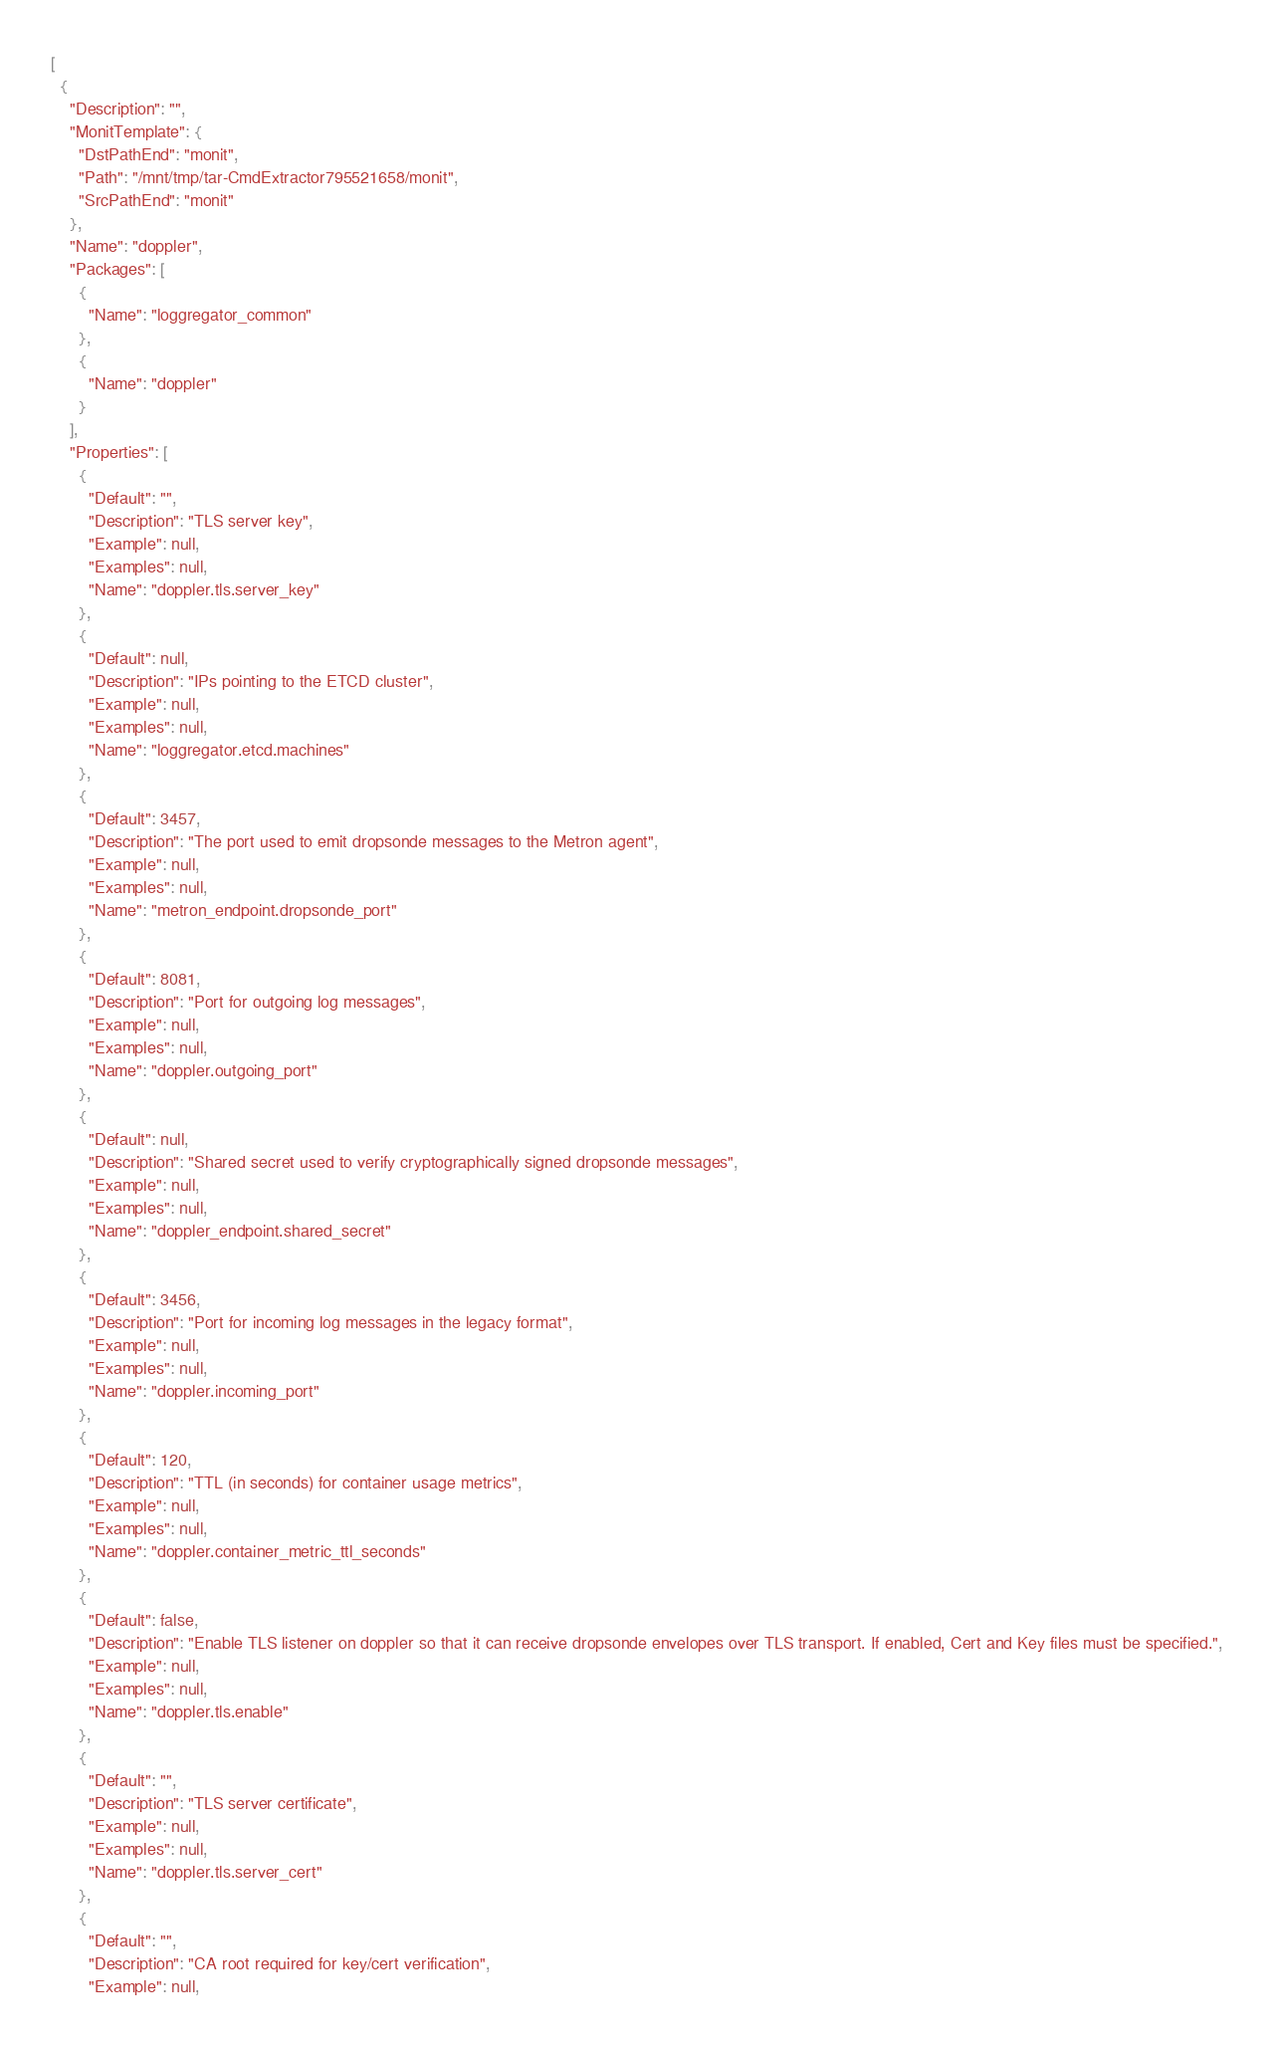Convert code to text. <code><loc_0><loc_0><loc_500><loc_500><_YAML_>[
  {
    "Description": "",
    "MonitTemplate": {
      "DstPathEnd": "monit",
      "Path": "/mnt/tmp/tar-CmdExtractor795521658/monit",
      "SrcPathEnd": "monit"
    },
    "Name": "doppler",
    "Packages": [
      {
        "Name": "loggregator_common"
      },
      {
        "Name": "doppler"
      }
    ],
    "Properties": [
      {
        "Default": "",
        "Description": "TLS server key",
        "Example": null,
        "Examples": null,
        "Name": "doppler.tls.server_key"
      },
      {
        "Default": null,
        "Description": "IPs pointing to the ETCD cluster",
        "Example": null,
        "Examples": null,
        "Name": "loggregator.etcd.machines"
      },
      {
        "Default": 3457,
        "Description": "The port used to emit dropsonde messages to the Metron agent",
        "Example": null,
        "Examples": null,
        "Name": "metron_endpoint.dropsonde_port"
      },
      {
        "Default": 8081,
        "Description": "Port for outgoing log messages",
        "Example": null,
        "Examples": null,
        "Name": "doppler.outgoing_port"
      },
      {
        "Default": null,
        "Description": "Shared secret used to verify cryptographically signed dropsonde messages",
        "Example": null,
        "Examples": null,
        "Name": "doppler_endpoint.shared_secret"
      },
      {
        "Default": 3456,
        "Description": "Port for incoming log messages in the legacy format",
        "Example": null,
        "Examples": null,
        "Name": "doppler.incoming_port"
      },
      {
        "Default": 120,
        "Description": "TTL (in seconds) for container usage metrics",
        "Example": null,
        "Examples": null,
        "Name": "doppler.container_metric_ttl_seconds"
      },
      {
        "Default": false,
        "Description": "Enable TLS listener on doppler so that it can receive dropsonde envelopes over TLS transport. If enabled, Cert and Key files must be specified.",
        "Example": null,
        "Examples": null,
        "Name": "doppler.tls.enable"
      },
      {
        "Default": "",
        "Description": "TLS server certificate",
        "Example": null,
        "Examples": null,
        "Name": "doppler.tls.server_cert"
      },
      {
        "Default": "",
        "Description": "CA root required for key/cert verification",
        "Example": null,</code> 